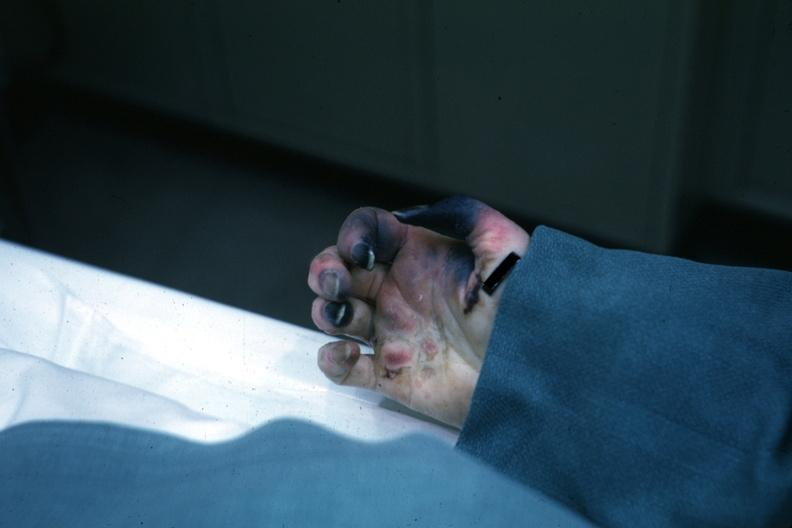what does exact cause know?
Answer the question using a single word or phrase. Shock vs emboli 